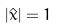Convert formula to latex. <formula><loc_0><loc_0><loc_500><loc_500>| { \hat { x } } | = 1</formula> 